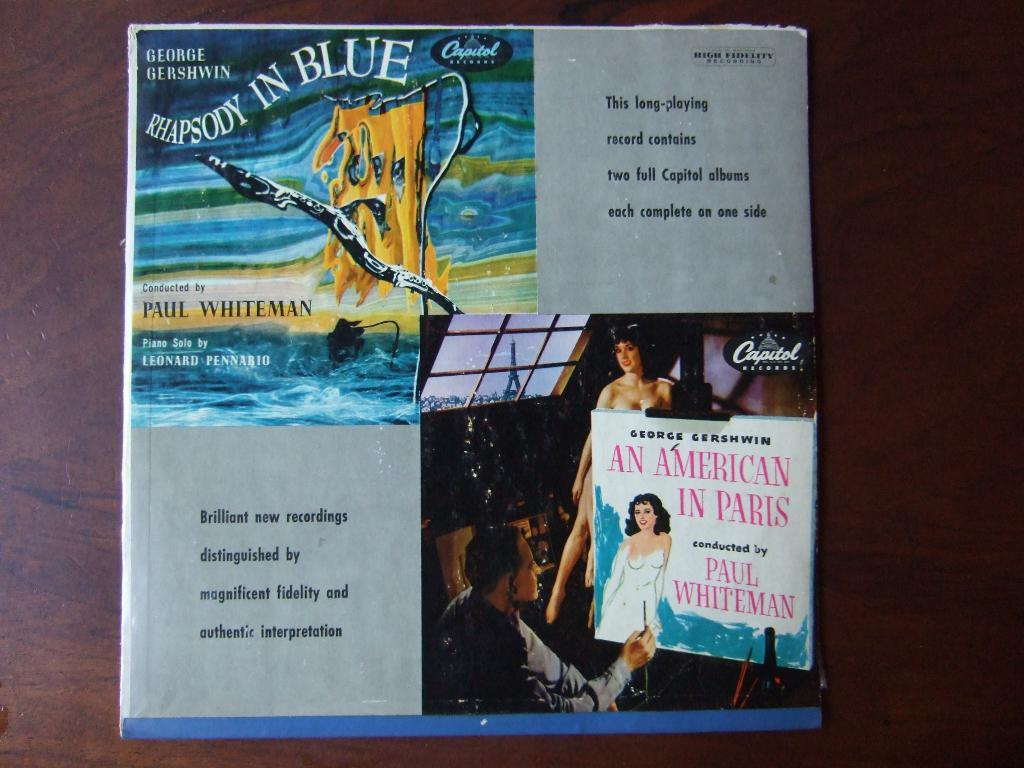<image>
Create a compact narrative representing the image presented. "Rhapsody In Blue" and "An American In Paris" are on record. 